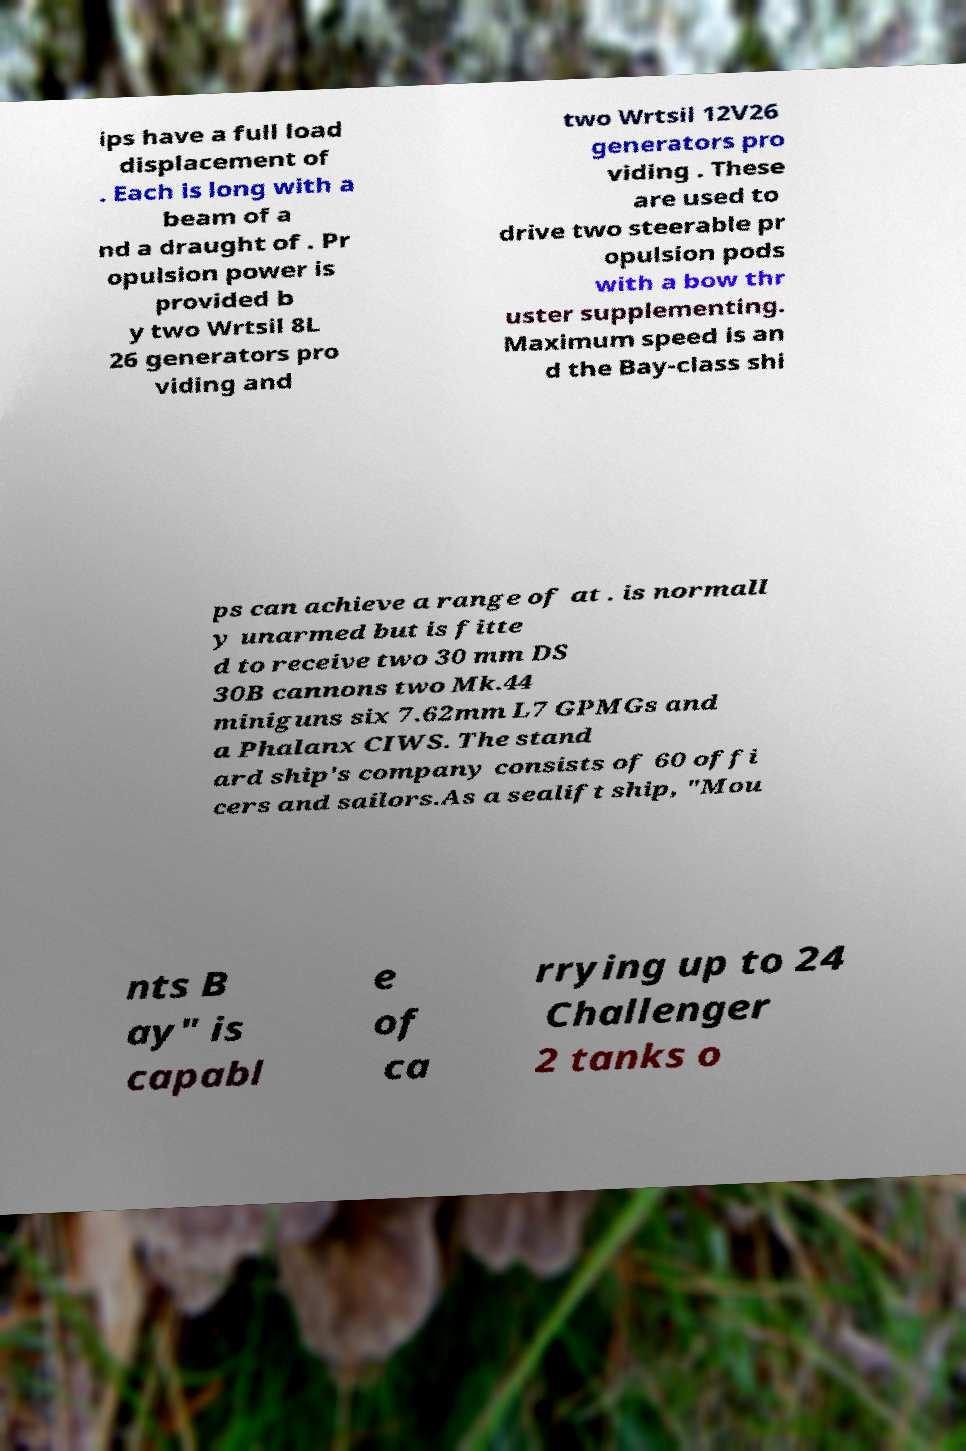Can you accurately transcribe the text from the provided image for me? ips have a full load displacement of . Each is long with a beam of a nd a draught of . Pr opulsion power is provided b y two Wrtsil 8L 26 generators pro viding and two Wrtsil 12V26 generators pro viding . These are used to drive two steerable pr opulsion pods with a bow thr uster supplementing. Maximum speed is an d the Bay-class shi ps can achieve a range of at . is normall y unarmed but is fitte d to receive two 30 mm DS 30B cannons two Mk.44 miniguns six 7.62mm L7 GPMGs and a Phalanx CIWS. The stand ard ship's company consists of 60 offi cers and sailors.As a sealift ship, "Mou nts B ay" is capabl e of ca rrying up to 24 Challenger 2 tanks o 